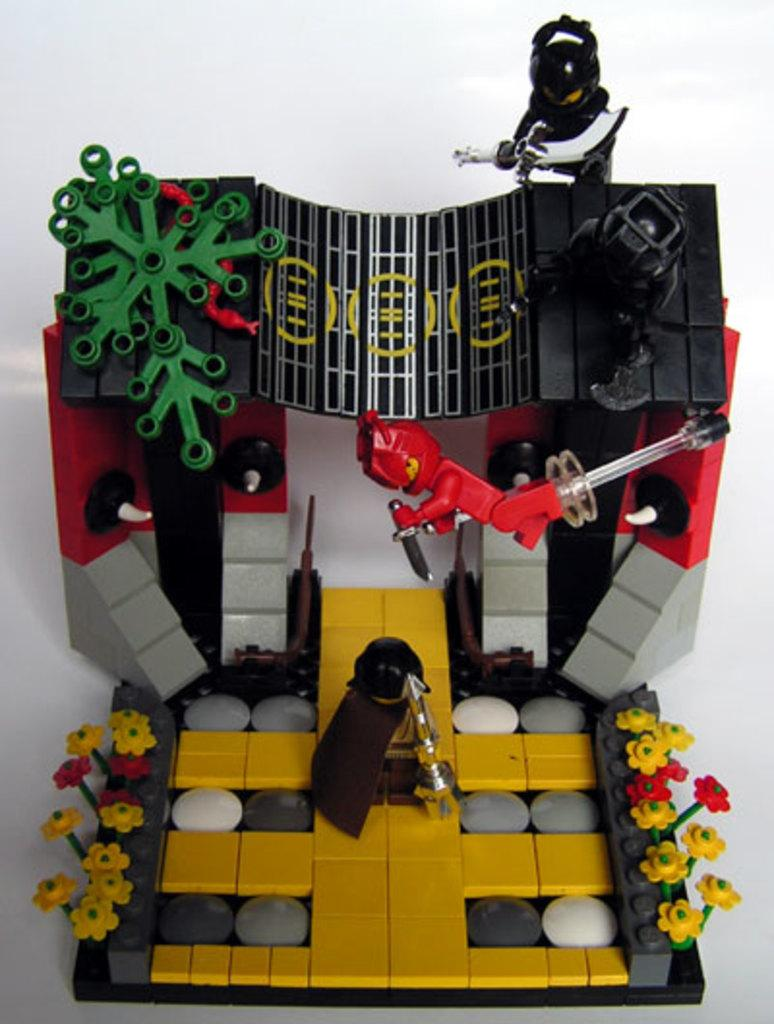What type of toys are featured in the image? There are Lego figures in the image. Can you describe the colors of the Lego figures? The Lego figures are in various colors, including green, red, yellow, grey, and black. What is the color of the background in the image? The background of the image is white in color. How many matches are being used to light the quilt in the image? There are no matches or quilts present in the image; it features Lego figures on a white background. 